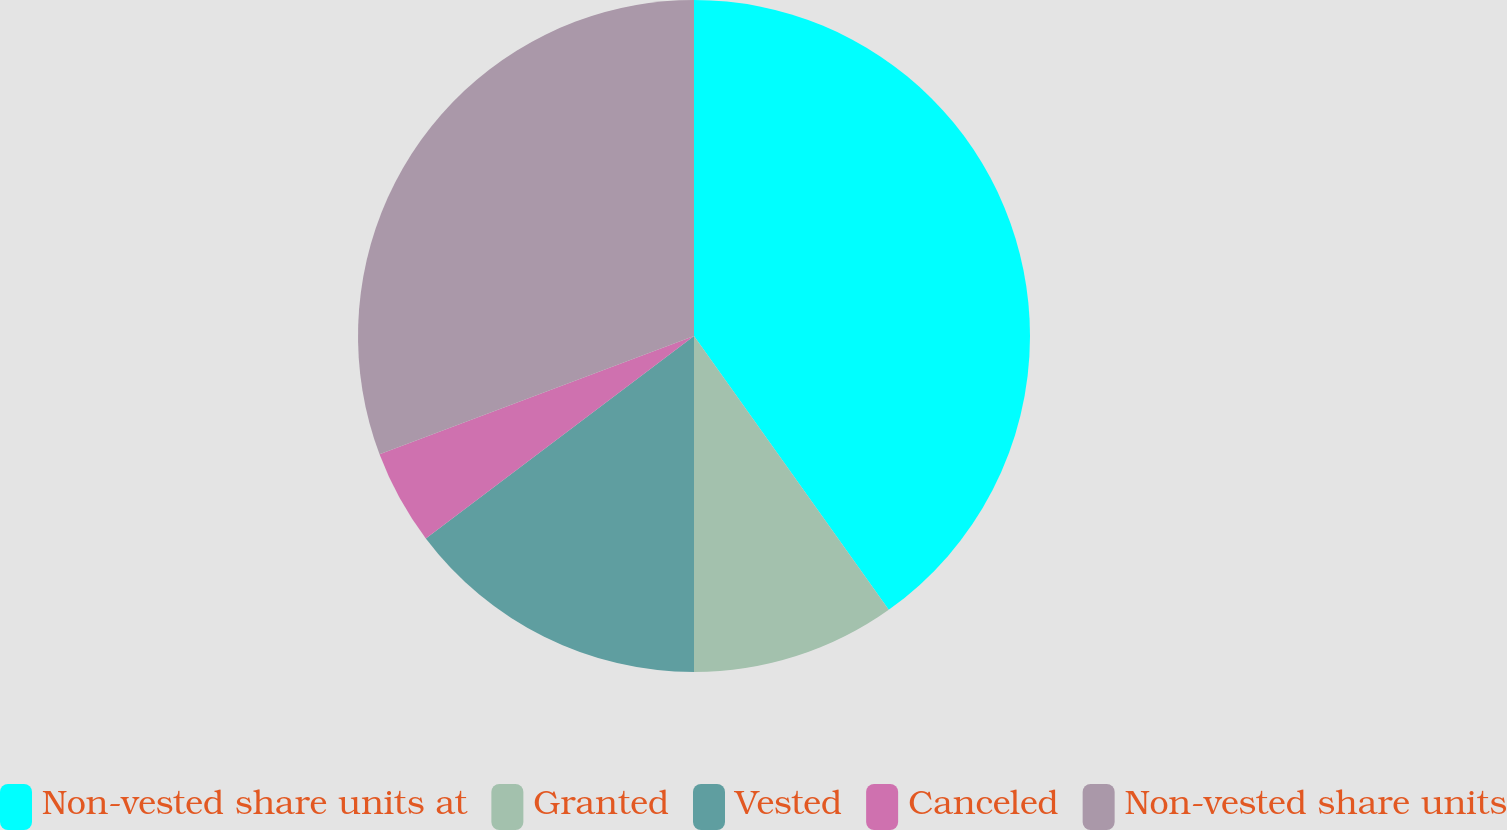Convert chart to OTSL. <chart><loc_0><loc_0><loc_500><loc_500><pie_chart><fcel>Non-vested share units at<fcel>Granted<fcel>Vested<fcel>Canceled<fcel>Non-vested share units<nl><fcel>40.16%<fcel>9.84%<fcel>14.71%<fcel>4.56%<fcel>30.73%<nl></chart> 